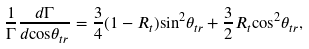<formula> <loc_0><loc_0><loc_500><loc_500>\frac { 1 } { \Gamma } \frac { d \Gamma } { d { \cos } \theta _ { t r } } = \frac { 3 } { 4 } ( 1 - R _ { t } ) { \sin } ^ { 2 } \theta _ { t r } + \frac { 3 } { 2 } R _ { t } { \cos } ^ { 2 } \theta _ { t r } ,</formula> 